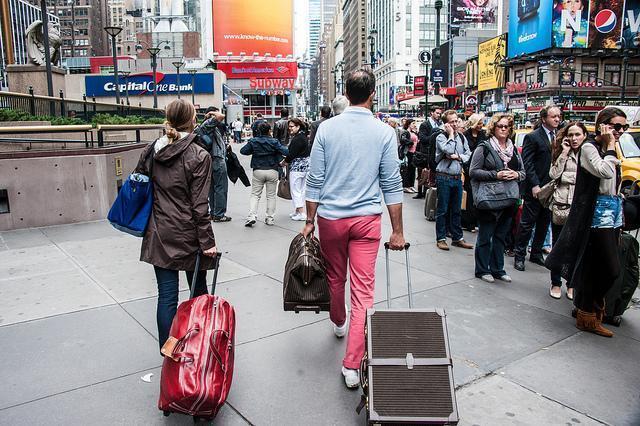The Red white and blue circular emblem on the visible billboard here advertises for what company?
Answer the question by selecting the correct answer among the 4 following choices.
Options: Keds, pepsi, coke, bank america. Pepsi. 